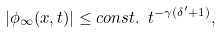<formula> <loc_0><loc_0><loc_500><loc_500>| \phi _ { \infty } ( x , t ) | \leq c o n s t . \text { } t ^ { - \gamma ( \delta ^ { \prime } + 1 ) } ,</formula> 